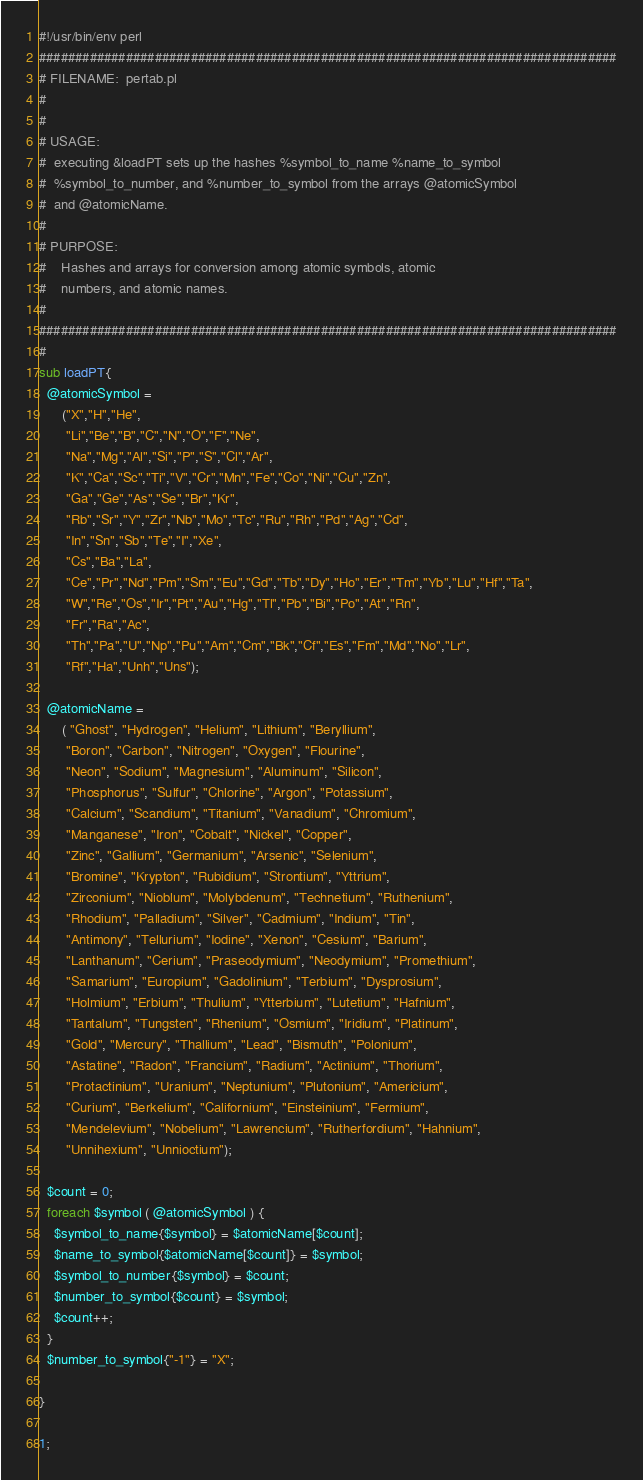<code> <loc_0><loc_0><loc_500><loc_500><_Perl_>#!/usr/bin/env perl
################################################################################
# FILENAME:  pertab.pl
#
#
# USAGE:
#  executing &loadPT sets up the hashes %symbol_to_name %name_to_symbol
#  %symbol_to_number, and %number_to_symbol from the arrays @atomicSymbol
#  and @atomicName.
#
# PURPOSE:
#    Hashes and arrays for conversion among atomic symbols, atomic 
#    numbers, and atomic names. 
# 
################################################################################
#
sub loadPT{
  @atomicSymbol = 
      ("X","H","He",
       "Li","Be","B","C","N","O","F","Ne",
       "Na","Mg","Al","Si","P","S","Cl","Ar",
       "K","Ca","Sc","Ti","V","Cr","Mn","Fe","Co","Ni","Cu","Zn",
       "Ga","Ge","As","Se","Br","Kr",
       "Rb","Sr","Y","Zr","Nb","Mo","Tc","Ru","Rh","Pd","Ag","Cd",
       "In","Sn","Sb","Te","I","Xe",
       "Cs","Ba","La",
       "Ce","Pr","Nd","Pm","Sm","Eu","Gd","Tb","Dy","Ho","Er","Tm","Yb","Lu","Hf","Ta",
       "W","Re","Os","Ir","Pt","Au","Hg","Tl","Pb","Bi","Po","At","Rn",
       "Fr","Ra","Ac",
       "Th","Pa","U","Np","Pu","Am","Cm","Bk","Cf","Es","Fm","Md","No","Lr",
       "Rf","Ha","Unh","Uns");

  @atomicName = 
      ( "Ghost", "Hydrogen", "Helium", "Lithium", "Beryllium", 
       "Boron", "Carbon", "Nitrogen", "Oxygen", "Flourine", 
       "Neon", "Sodium", "Magnesium", "Aluminum", "Silicon",
       "Phosphorus", "Sulfur", "Chlorine", "Argon", "Potassium",
       "Calcium", "Scandium", "Titanium", "Vanadium", "Chromium",
       "Manganese", "Iron", "Cobalt", "Nickel", "Copper",
       "Zinc", "Gallium", "Germanium", "Arsenic", "Selenium",
       "Bromine", "Krypton", "Rubidium", "Strontium", "Yttrium",
       "Zirconium", "Nioblum", "Molybdenum", "Technetium", "Ruthenium",
       "Rhodium", "Palladium", "Silver", "Cadmium", "Indium", "Tin",
       "Antimony", "Tellurium", "Iodine", "Xenon", "Cesium", "Barium",
       "Lanthanum", "Cerium", "Praseodymium", "Neodymium", "Promethium",
       "Samarium", "Europium", "Gadolinium", "Terbium", "Dysprosium",
       "Holmium", "Erbium", "Thulium", "Ytterbium", "Lutetium", "Hafnium",
       "Tantalum", "Tungsten", "Rhenium", "Osmium", "Iridium", "Platinum",
       "Gold", "Mercury", "Thallium", "Lead", "Bismuth", "Polonium",
       "Astatine", "Radon", "Francium", "Radium", "Actinium", "Thorium",
       "Protactinium", "Uranium", "Neptunium", "Plutonium", "Americium",
       "Curium", "Berkelium", "Californium", "Einsteinium", "Fermium",
       "Mendelevium", "Nobelium", "Lawrencium", "Rutherfordium", "Hahnium",
       "Unnihexium", "Unnioctium");

  $count = 0;
  foreach $symbol ( @atomicSymbol ) {
    $symbol_to_name{$symbol} = $atomicName[$count];
    $name_to_symbol{$atomicName[$count]} = $symbol;
    $symbol_to_number{$symbol} = $count;
    $number_to_symbol{$count} = $symbol;
    $count++;
  }
  $number_to_symbol{"-1"} = "X";

}

1;
</code> 